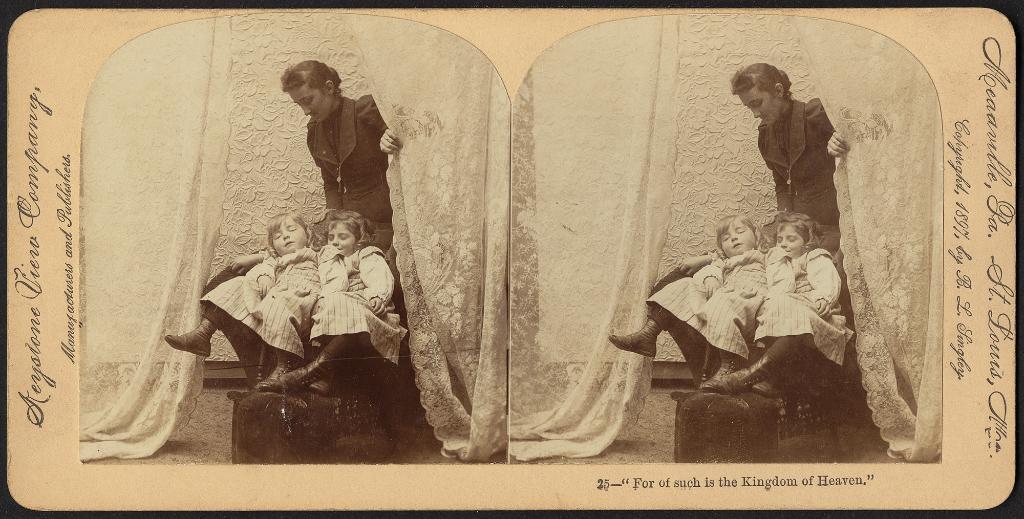In one or two sentences, can you explain what this image depicts? In this picture we can see a photo collage of three people and some text on a board. 